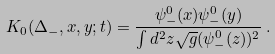Convert formula to latex. <formula><loc_0><loc_0><loc_500><loc_500>K _ { 0 } ( \Delta _ { - } , x , y ; t ) = \frac { \psi ^ { 0 } _ { - } ( x ) \psi ^ { 0 } _ { - } ( y ) } { \int d ^ { 2 } z \sqrt { g } ( \psi ^ { 0 } _ { - } ( z ) ) ^ { 2 } } \, .</formula> 